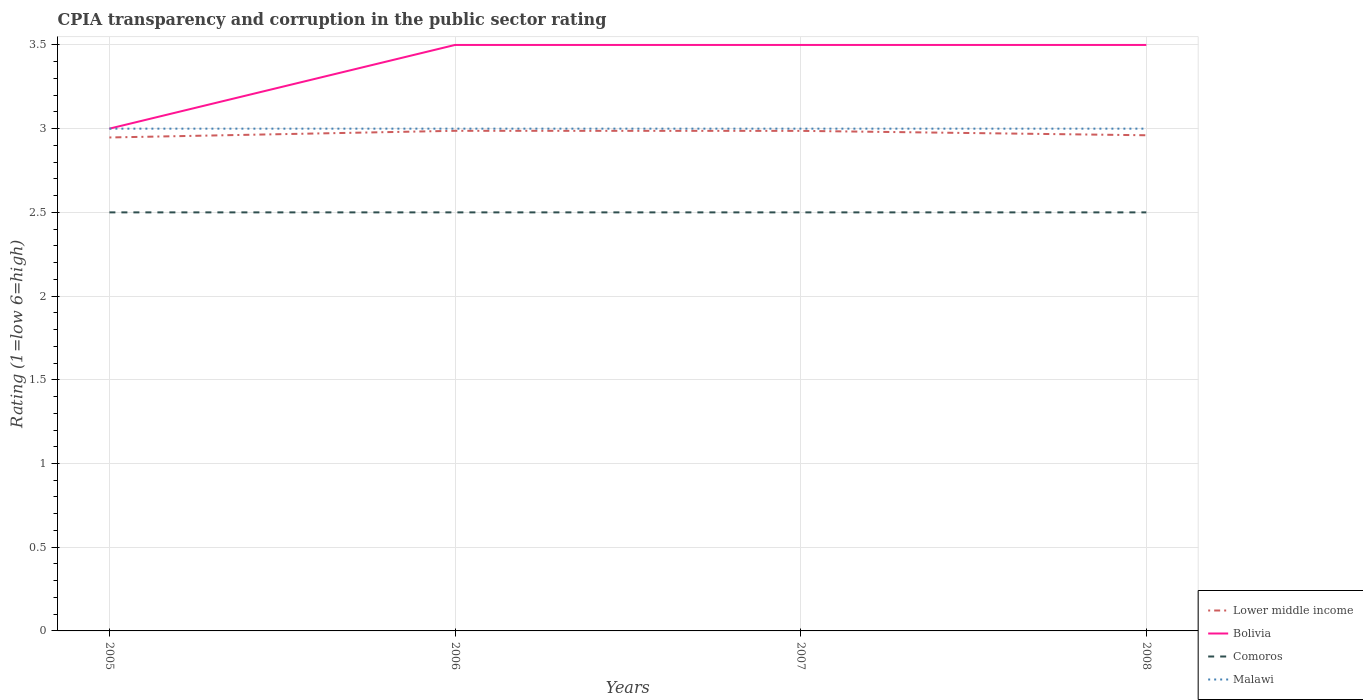How many different coloured lines are there?
Provide a succinct answer. 4. Does the line corresponding to Bolivia intersect with the line corresponding to Comoros?
Your answer should be very brief. No. Across all years, what is the maximum CPIA rating in Malawi?
Your response must be concise. 3. In which year was the CPIA rating in Lower middle income maximum?
Your response must be concise. 2005. What is the difference between the highest and the second highest CPIA rating in Comoros?
Ensure brevity in your answer.  0. What is the difference between the highest and the lowest CPIA rating in Bolivia?
Offer a terse response. 3. Is the CPIA rating in Malawi strictly greater than the CPIA rating in Lower middle income over the years?
Provide a succinct answer. No. How many lines are there?
Ensure brevity in your answer.  4. Does the graph contain any zero values?
Ensure brevity in your answer.  No. Does the graph contain grids?
Give a very brief answer. Yes. Where does the legend appear in the graph?
Keep it short and to the point. Bottom right. What is the title of the graph?
Your answer should be very brief. CPIA transparency and corruption in the public sector rating. Does "Algeria" appear as one of the legend labels in the graph?
Ensure brevity in your answer.  No. What is the label or title of the X-axis?
Your answer should be compact. Years. What is the label or title of the Y-axis?
Ensure brevity in your answer.  Rating (1=low 6=high). What is the Rating (1=low 6=high) in Lower middle income in 2005?
Make the answer very short. 2.95. What is the Rating (1=low 6=high) in Comoros in 2005?
Your answer should be compact. 2.5. What is the Rating (1=low 6=high) of Malawi in 2005?
Give a very brief answer. 3. What is the Rating (1=low 6=high) of Lower middle income in 2006?
Your response must be concise. 2.99. What is the Rating (1=low 6=high) of Comoros in 2006?
Provide a succinct answer. 2.5. What is the Rating (1=low 6=high) in Lower middle income in 2007?
Keep it short and to the point. 2.99. What is the Rating (1=low 6=high) of Bolivia in 2007?
Offer a very short reply. 3.5. What is the Rating (1=low 6=high) in Lower middle income in 2008?
Keep it short and to the point. 2.96. What is the Rating (1=low 6=high) of Bolivia in 2008?
Your response must be concise. 3.5. What is the Rating (1=low 6=high) of Comoros in 2008?
Keep it short and to the point. 2.5. What is the Rating (1=low 6=high) in Malawi in 2008?
Offer a terse response. 3. Across all years, what is the maximum Rating (1=low 6=high) in Lower middle income?
Your response must be concise. 2.99. Across all years, what is the maximum Rating (1=low 6=high) of Bolivia?
Your answer should be compact. 3.5. Across all years, what is the minimum Rating (1=low 6=high) of Lower middle income?
Provide a short and direct response. 2.95. What is the total Rating (1=low 6=high) in Lower middle income in the graph?
Your answer should be very brief. 11.88. What is the total Rating (1=low 6=high) of Bolivia in the graph?
Offer a very short reply. 13.5. What is the total Rating (1=low 6=high) of Malawi in the graph?
Your answer should be very brief. 12. What is the difference between the Rating (1=low 6=high) in Lower middle income in 2005 and that in 2006?
Give a very brief answer. -0.04. What is the difference between the Rating (1=low 6=high) of Bolivia in 2005 and that in 2006?
Your response must be concise. -0.5. What is the difference between the Rating (1=low 6=high) in Malawi in 2005 and that in 2006?
Keep it short and to the point. 0. What is the difference between the Rating (1=low 6=high) in Lower middle income in 2005 and that in 2007?
Your answer should be very brief. -0.04. What is the difference between the Rating (1=low 6=high) of Comoros in 2005 and that in 2007?
Provide a short and direct response. 0. What is the difference between the Rating (1=low 6=high) in Lower middle income in 2005 and that in 2008?
Keep it short and to the point. -0.01. What is the difference between the Rating (1=low 6=high) in Bolivia in 2005 and that in 2008?
Give a very brief answer. -0.5. What is the difference between the Rating (1=low 6=high) of Bolivia in 2006 and that in 2007?
Provide a short and direct response. 0. What is the difference between the Rating (1=low 6=high) of Comoros in 2006 and that in 2007?
Ensure brevity in your answer.  0. What is the difference between the Rating (1=low 6=high) in Malawi in 2006 and that in 2007?
Provide a short and direct response. 0. What is the difference between the Rating (1=low 6=high) in Lower middle income in 2006 and that in 2008?
Keep it short and to the point. 0.03. What is the difference between the Rating (1=low 6=high) in Bolivia in 2006 and that in 2008?
Your answer should be very brief. 0. What is the difference between the Rating (1=low 6=high) in Comoros in 2006 and that in 2008?
Give a very brief answer. 0. What is the difference between the Rating (1=low 6=high) of Malawi in 2006 and that in 2008?
Ensure brevity in your answer.  0. What is the difference between the Rating (1=low 6=high) of Lower middle income in 2007 and that in 2008?
Offer a very short reply. 0.03. What is the difference between the Rating (1=low 6=high) in Malawi in 2007 and that in 2008?
Provide a succinct answer. 0. What is the difference between the Rating (1=low 6=high) in Lower middle income in 2005 and the Rating (1=low 6=high) in Bolivia in 2006?
Keep it short and to the point. -0.55. What is the difference between the Rating (1=low 6=high) in Lower middle income in 2005 and the Rating (1=low 6=high) in Comoros in 2006?
Provide a succinct answer. 0.45. What is the difference between the Rating (1=low 6=high) of Lower middle income in 2005 and the Rating (1=low 6=high) of Malawi in 2006?
Keep it short and to the point. -0.05. What is the difference between the Rating (1=low 6=high) of Comoros in 2005 and the Rating (1=low 6=high) of Malawi in 2006?
Provide a succinct answer. -0.5. What is the difference between the Rating (1=low 6=high) of Lower middle income in 2005 and the Rating (1=low 6=high) of Bolivia in 2007?
Your response must be concise. -0.55. What is the difference between the Rating (1=low 6=high) in Lower middle income in 2005 and the Rating (1=low 6=high) in Comoros in 2007?
Your answer should be very brief. 0.45. What is the difference between the Rating (1=low 6=high) in Lower middle income in 2005 and the Rating (1=low 6=high) in Malawi in 2007?
Keep it short and to the point. -0.05. What is the difference between the Rating (1=low 6=high) of Bolivia in 2005 and the Rating (1=low 6=high) of Comoros in 2007?
Give a very brief answer. 0.5. What is the difference between the Rating (1=low 6=high) in Bolivia in 2005 and the Rating (1=low 6=high) in Malawi in 2007?
Keep it short and to the point. 0. What is the difference between the Rating (1=low 6=high) in Comoros in 2005 and the Rating (1=low 6=high) in Malawi in 2007?
Keep it short and to the point. -0.5. What is the difference between the Rating (1=low 6=high) of Lower middle income in 2005 and the Rating (1=low 6=high) of Bolivia in 2008?
Keep it short and to the point. -0.55. What is the difference between the Rating (1=low 6=high) of Lower middle income in 2005 and the Rating (1=low 6=high) of Comoros in 2008?
Give a very brief answer. 0.45. What is the difference between the Rating (1=low 6=high) in Lower middle income in 2005 and the Rating (1=low 6=high) in Malawi in 2008?
Provide a short and direct response. -0.05. What is the difference between the Rating (1=low 6=high) of Bolivia in 2005 and the Rating (1=low 6=high) of Comoros in 2008?
Provide a short and direct response. 0.5. What is the difference between the Rating (1=low 6=high) of Bolivia in 2005 and the Rating (1=low 6=high) of Malawi in 2008?
Offer a very short reply. 0. What is the difference between the Rating (1=low 6=high) of Comoros in 2005 and the Rating (1=low 6=high) of Malawi in 2008?
Make the answer very short. -0.5. What is the difference between the Rating (1=low 6=high) of Lower middle income in 2006 and the Rating (1=low 6=high) of Bolivia in 2007?
Make the answer very short. -0.51. What is the difference between the Rating (1=low 6=high) of Lower middle income in 2006 and the Rating (1=low 6=high) of Comoros in 2007?
Give a very brief answer. 0.49. What is the difference between the Rating (1=low 6=high) of Lower middle income in 2006 and the Rating (1=low 6=high) of Malawi in 2007?
Provide a succinct answer. -0.01. What is the difference between the Rating (1=low 6=high) in Bolivia in 2006 and the Rating (1=low 6=high) in Comoros in 2007?
Make the answer very short. 1. What is the difference between the Rating (1=low 6=high) in Comoros in 2006 and the Rating (1=low 6=high) in Malawi in 2007?
Make the answer very short. -0.5. What is the difference between the Rating (1=low 6=high) in Lower middle income in 2006 and the Rating (1=low 6=high) in Bolivia in 2008?
Make the answer very short. -0.51. What is the difference between the Rating (1=low 6=high) in Lower middle income in 2006 and the Rating (1=low 6=high) in Comoros in 2008?
Provide a short and direct response. 0.49. What is the difference between the Rating (1=low 6=high) of Lower middle income in 2006 and the Rating (1=low 6=high) of Malawi in 2008?
Your answer should be compact. -0.01. What is the difference between the Rating (1=low 6=high) of Bolivia in 2006 and the Rating (1=low 6=high) of Malawi in 2008?
Ensure brevity in your answer.  0.5. What is the difference between the Rating (1=low 6=high) of Lower middle income in 2007 and the Rating (1=low 6=high) of Bolivia in 2008?
Provide a succinct answer. -0.51. What is the difference between the Rating (1=low 6=high) of Lower middle income in 2007 and the Rating (1=low 6=high) of Comoros in 2008?
Your answer should be very brief. 0.49. What is the difference between the Rating (1=low 6=high) of Lower middle income in 2007 and the Rating (1=low 6=high) of Malawi in 2008?
Keep it short and to the point. -0.01. What is the difference between the Rating (1=low 6=high) of Bolivia in 2007 and the Rating (1=low 6=high) of Malawi in 2008?
Offer a very short reply. 0.5. What is the average Rating (1=low 6=high) of Lower middle income per year?
Ensure brevity in your answer.  2.97. What is the average Rating (1=low 6=high) of Bolivia per year?
Make the answer very short. 3.38. What is the average Rating (1=low 6=high) of Malawi per year?
Give a very brief answer. 3. In the year 2005, what is the difference between the Rating (1=low 6=high) in Lower middle income and Rating (1=low 6=high) in Bolivia?
Provide a short and direct response. -0.05. In the year 2005, what is the difference between the Rating (1=low 6=high) of Lower middle income and Rating (1=low 6=high) of Comoros?
Make the answer very short. 0.45. In the year 2005, what is the difference between the Rating (1=low 6=high) in Lower middle income and Rating (1=low 6=high) in Malawi?
Give a very brief answer. -0.05. In the year 2005, what is the difference between the Rating (1=low 6=high) in Comoros and Rating (1=low 6=high) in Malawi?
Your response must be concise. -0.5. In the year 2006, what is the difference between the Rating (1=low 6=high) of Lower middle income and Rating (1=low 6=high) of Bolivia?
Keep it short and to the point. -0.51. In the year 2006, what is the difference between the Rating (1=low 6=high) of Lower middle income and Rating (1=low 6=high) of Comoros?
Ensure brevity in your answer.  0.49. In the year 2006, what is the difference between the Rating (1=low 6=high) in Lower middle income and Rating (1=low 6=high) in Malawi?
Offer a terse response. -0.01. In the year 2006, what is the difference between the Rating (1=low 6=high) of Bolivia and Rating (1=low 6=high) of Malawi?
Your response must be concise. 0.5. In the year 2006, what is the difference between the Rating (1=low 6=high) in Comoros and Rating (1=low 6=high) in Malawi?
Your answer should be compact. -0.5. In the year 2007, what is the difference between the Rating (1=low 6=high) of Lower middle income and Rating (1=low 6=high) of Bolivia?
Ensure brevity in your answer.  -0.51. In the year 2007, what is the difference between the Rating (1=low 6=high) of Lower middle income and Rating (1=low 6=high) of Comoros?
Give a very brief answer. 0.49. In the year 2007, what is the difference between the Rating (1=low 6=high) of Lower middle income and Rating (1=low 6=high) of Malawi?
Provide a succinct answer. -0.01. In the year 2007, what is the difference between the Rating (1=low 6=high) of Bolivia and Rating (1=low 6=high) of Comoros?
Provide a short and direct response. 1. In the year 2007, what is the difference between the Rating (1=low 6=high) of Comoros and Rating (1=low 6=high) of Malawi?
Give a very brief answer. -0.5. In the year 2008, what is the difference between the Rating (1=low 6=high) of Lower middle income and Rating (1=low 6=high) of Bolivia?
Give a very brief answer. -0.54. In the year 2008, what is the difference between the Rating (1=low 6=high) in Lower middle income and Rating (1=low 6=high) in Comoros?
Offer a very short reply. 0.46. In the year 2008, what is the difference between the Rating (1=low 6=high) of Lower middle income and Rating (1=low 6=high) of Malawi?
Provide a succinct answer. -0.04. In the year 2008, what is the difference between the Rating (1=low 6=high) in Bolivia and Rating (1=low 6=high) in Comoros?
Ensure brevity in your answer.  1. In the year 2008, what is the difference between the Rating (1=low 6=high) in Bolivia and Rating (1=low 6=high) in Malawi?
Offer a terse response. 0.5. In the year 2008, what is the difference between the Rating (1=low 6=high) of Comoros and Rating (1=low 6=high) of Malawi?
Make the answer very short. -0.5. What is the ratio of the Rating (1=low 6=high) in Lower middle income in 2005 to that in 2006?
Provide a succinct answer. 0.99. What is the ratio of the Rating (1=low 6=high) in Bolivia in 2005 to that in 2006?
Your response must be concise. 0.86. What is the ratio of the Rating (1=low 6=high) of Comoros in 2005 to that in 2006?
Make the answer very short. 1. What is the ratio of the Rating (1=low 6=high) in Lower middle income in 2005 to that in 2008?
Your response must be concise. 1. What is the ratio of the Rating (1=low 6=high) in Bolivia in 2005 to that in 2008?
Your answer should be compact. 0.86. What is the ratio of the Rating (1=low 6=high) in Comoros in 2005 to that in 2008?
Your response must be concise. 1. What is the ratio of the Rating (1=low 6=high) in Comoros in 2006 to that in 2007?
Ensure brevity in your answer.  1. What is the ratio of the Rating (1=low 6=high) of Bolivia in 2006 to that in 2008?
Give a very brief answer. 1. What is the ratio of the Rating (1=low 6=high) in Comoros in 2006 to that in 2008?
Keep it short and to the point. 1. What is the ratio of the Rating (1=low 6=high) of Malawi in 2006 to that in 2008?
Offer a very short reply. 1. What is the ratio of the Rating (1=low 6=high) of Lower middle income in 2007 to that in 2008?
Provide a succinct answer. 1.01. What is the ratio of the Rating (1=low 6=high) in Bolivia in 2007 to that in 2008?
Your answer should be very brief. 1. What is the difference between the highest and the lowest Rating (1=low 6=high) of Lower middle income?
Your response must be concise. 0.04. What is the difference between the highest and the lowest Rating (1=low 6=high) in Bolivia?
Keep it short and to the point. 0.5. 